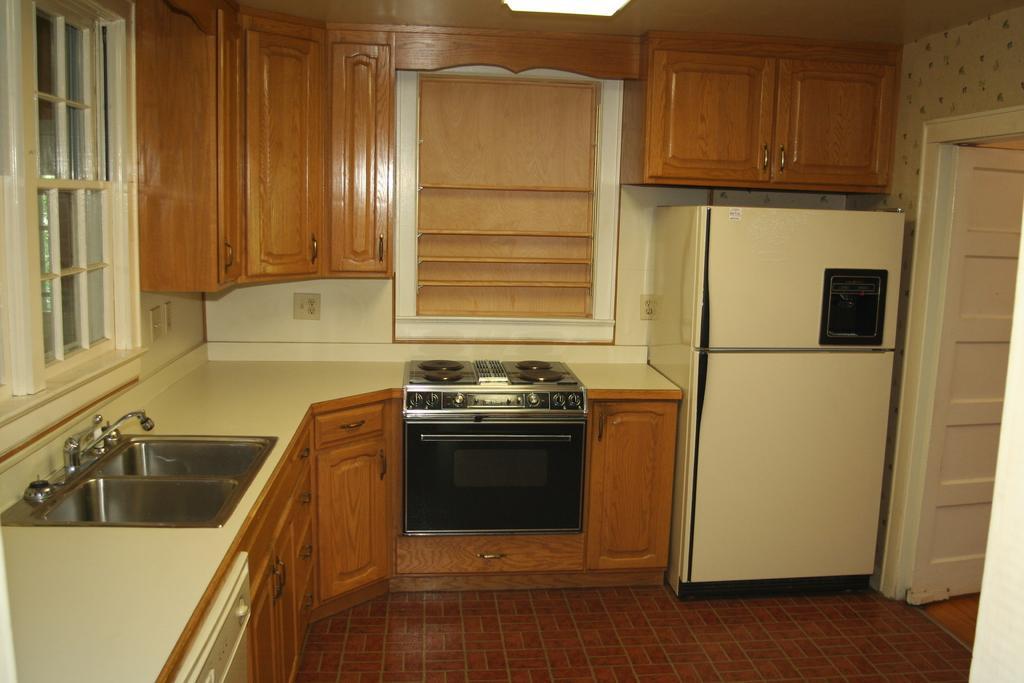How would you summarize this image in a sentence or two? This image is taken in the kitchen. On the left side of the image there are windows, below the window there is a sink on the platform and there is a stove, below the stove there is an oven and some cupboards, above the stove there are cupboards and there is a refrigerator, beside the refrigerator there is an open door. 